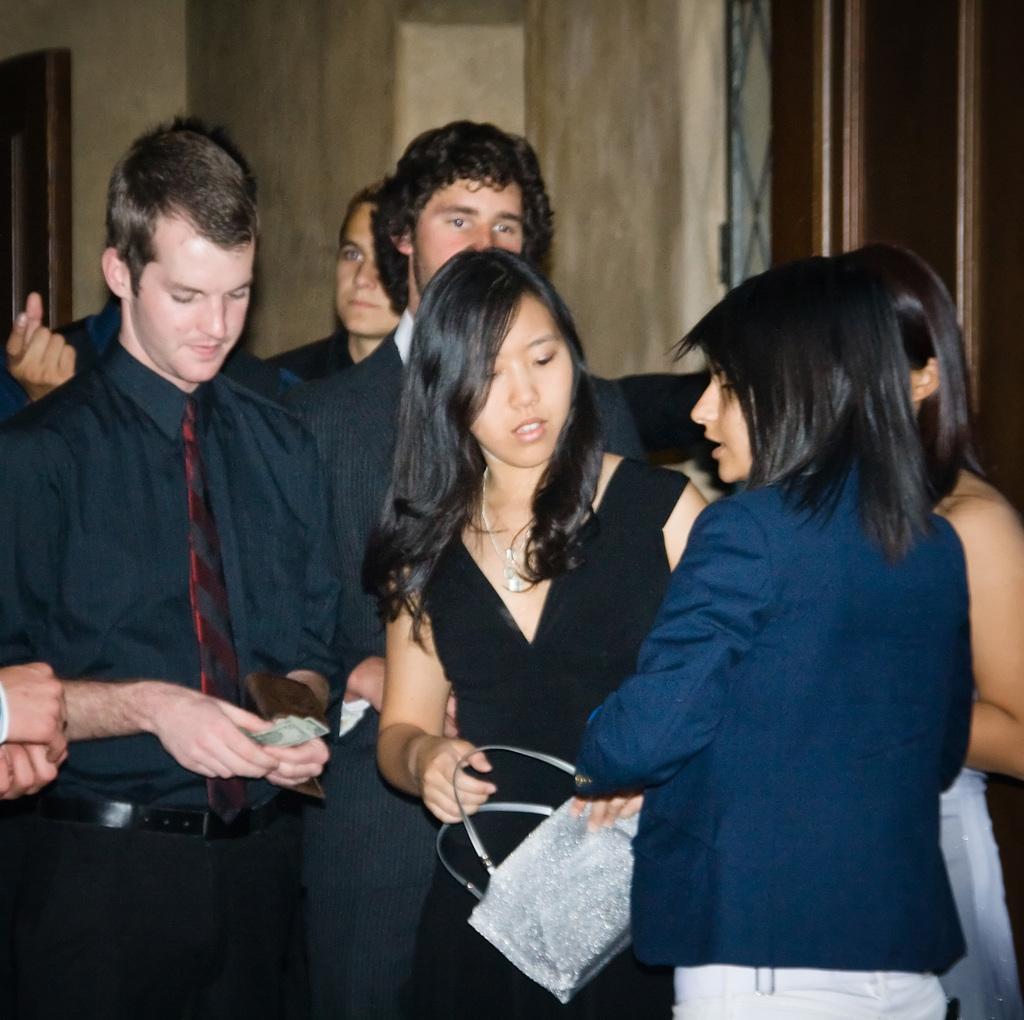In one or two sentences, can you explain what this image depicts? In this image, we can see a group of people standing and wearing clothes. There is a person in the middle of the image holding a bag with her hand. There is a person on the left side of the image holding money with his hands. 